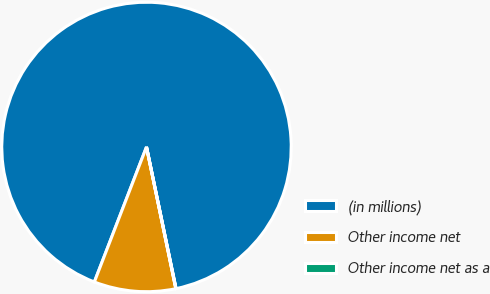<chart> <loc_0><loc_0><loc_500><loc_500><pie_chart><fcel>(in millions)<fcel>Other income net<fcel>Other income net as a<nl><fcel>90.85%<fcel>9.11%<fcel>0.03%<nl></chart> 